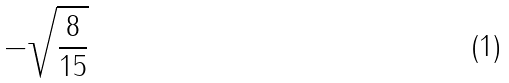Convert formula to latex. <formula><loc_0><loc_0><loc_500><loc_500>- \sqrt { \frac { 8 } { 1 5 } }</formula> 